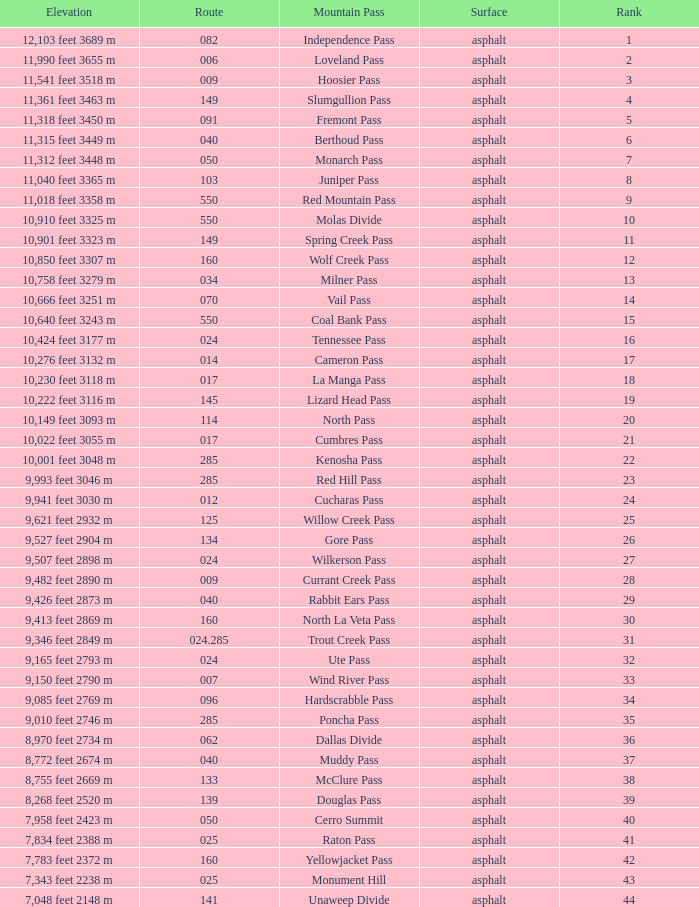What is the Surface of the Route less than 7? Asphalt. 